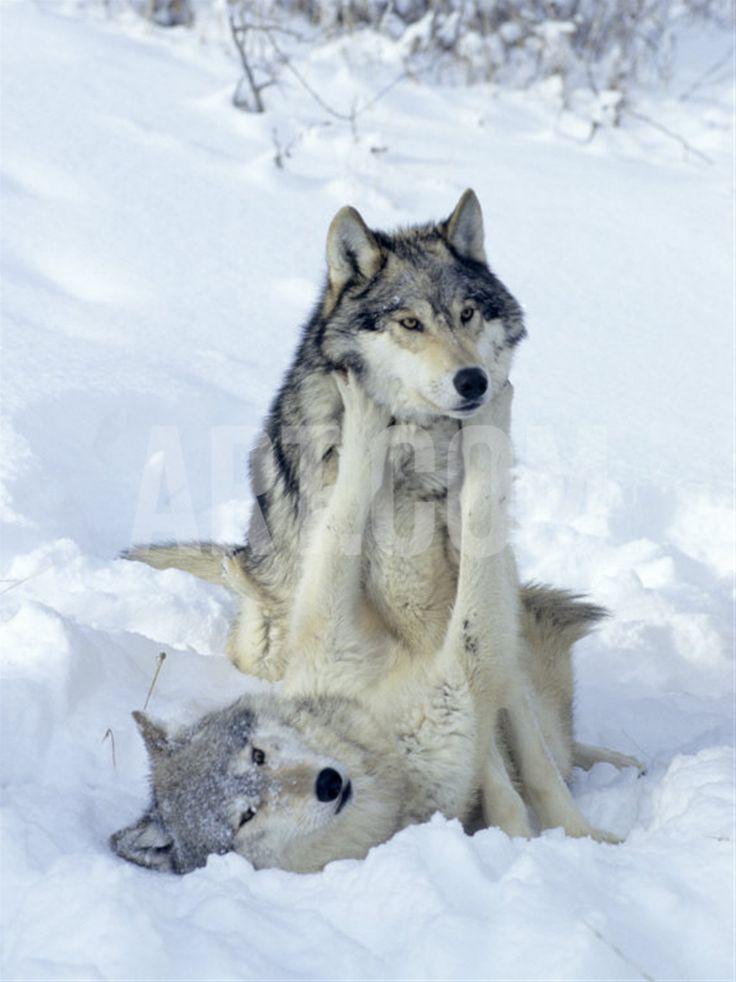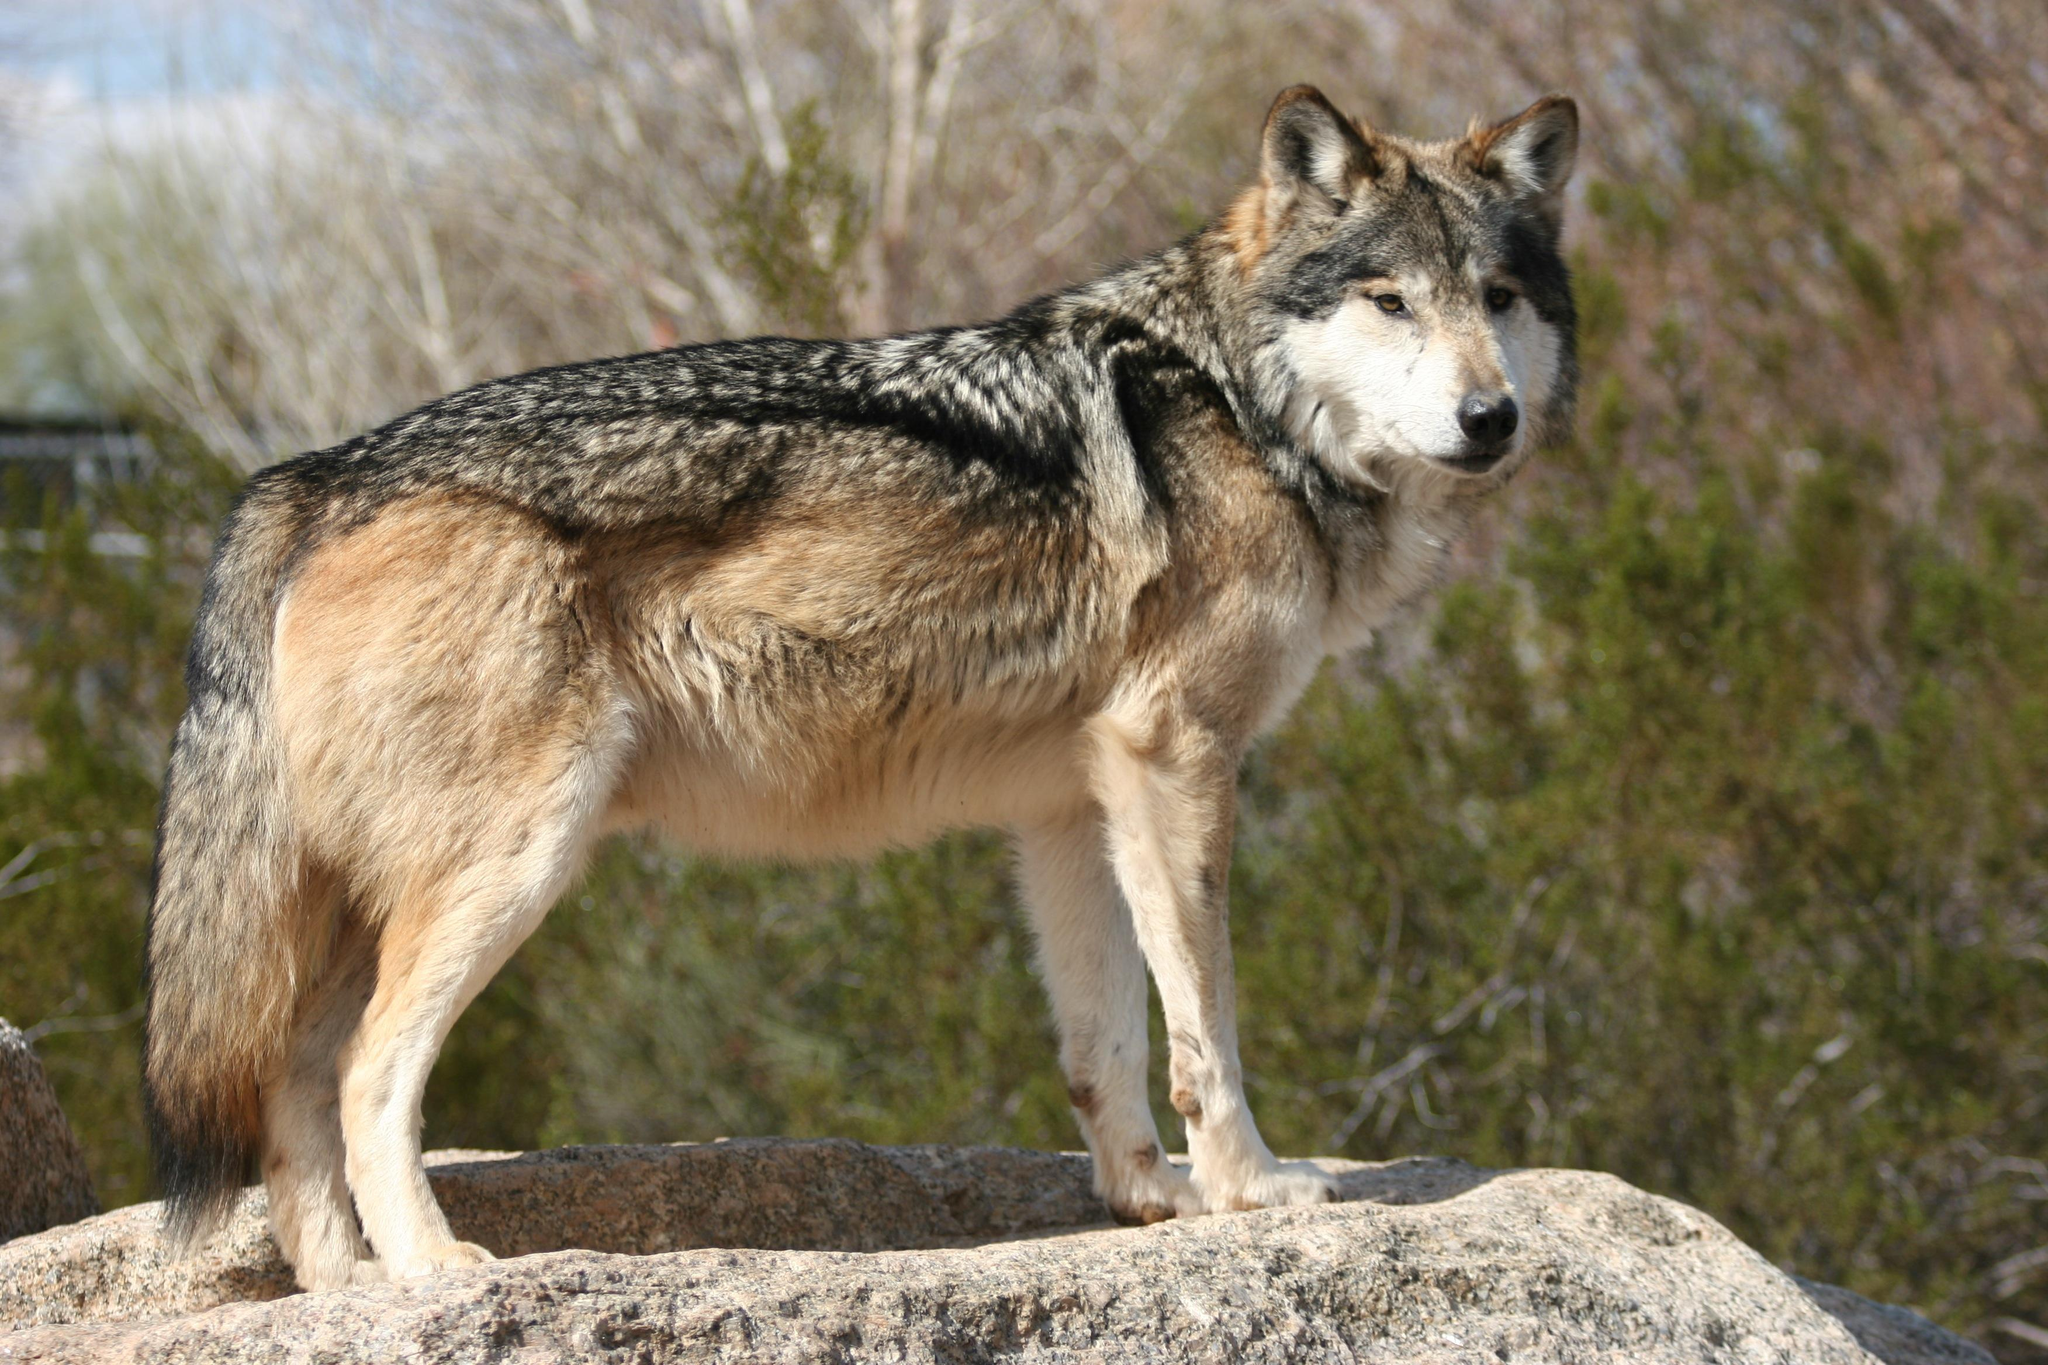The first image is the image on the left, the second image is the image on the right. For the images shown, is this caption "The wolf in the right image is facing towards the right." true? Answer yes or no. Yes. The first image is the image on the left, the second image is the image on the right. Considering the images on both sides, is "One image includes at least three standing similar-looking wolves in a snowy scene." valid? Answer yes or no. No. 